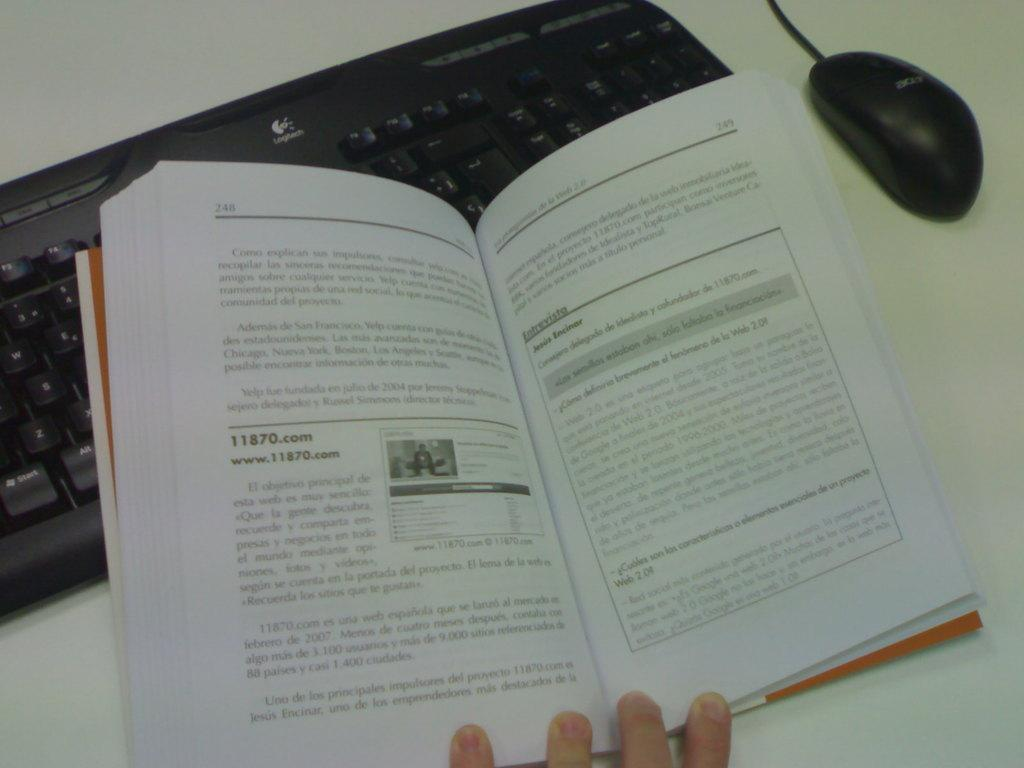<image>
Provide a brief description of the given image. On page 248 of this book you can find the text www.11870.com. 